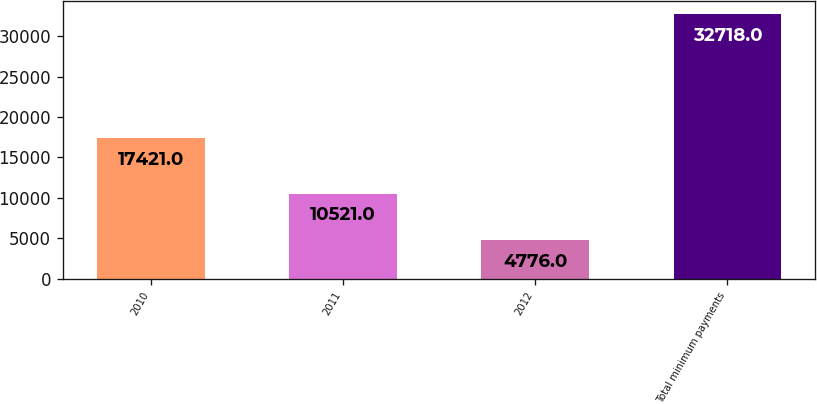Convert chart to OTSL. <chart><loc_0><loc_0><loc_500><loc_500><bar_chart><fcel>2010<fcel>2011<fcel>2012<fcel>Total minimum payments<nl><fcel>17421<fcel>10521<fcel>4776<fcel>32718<nl></chart> 